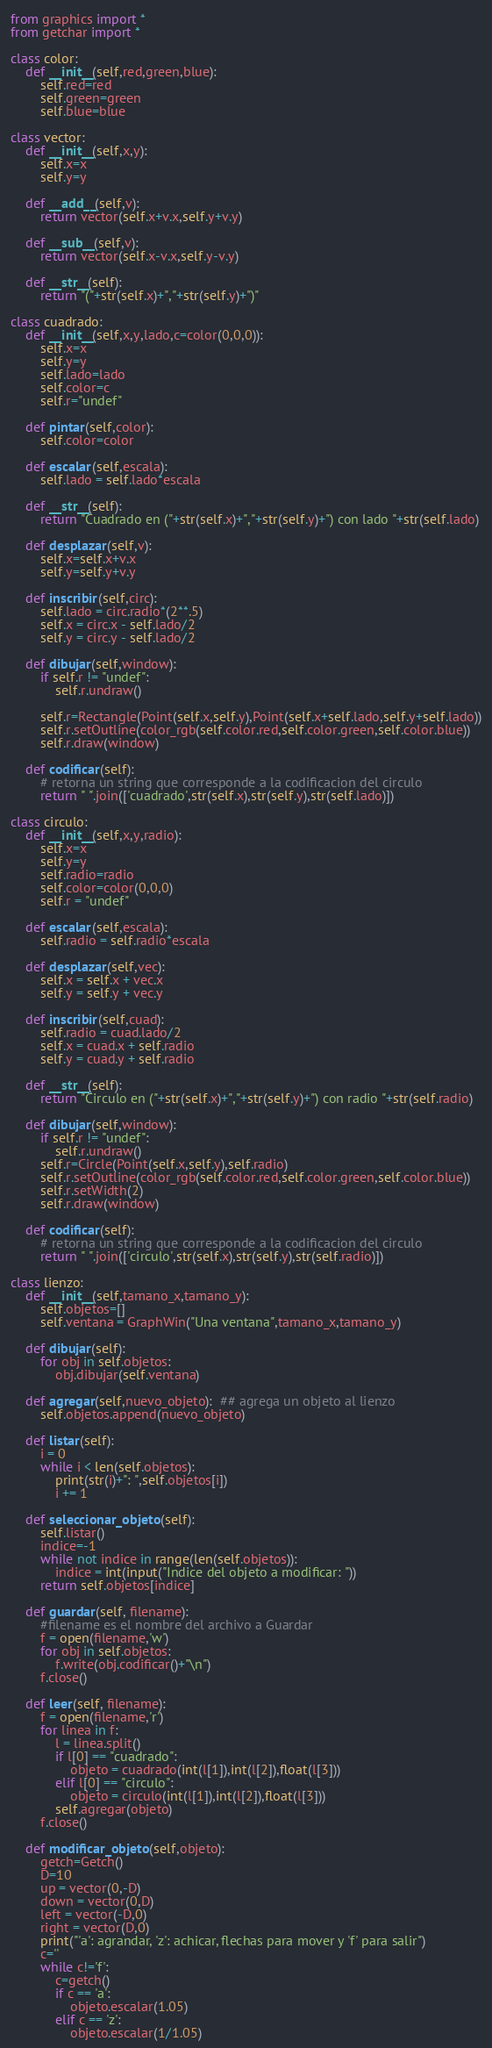Convert code to text. <code><loc_0><loc_0><loc_500><loc_500><_Python_>from graphics import *
from getchar import *

class color:
    def __init__(self,red,green,blue):
        self.red=red
        self.green=green
        self.blue=blue

class vector:
    def __init__(self,x,y):
        self.x=x
        self.y=y

    def __add__(self,v):
        return vector(self.x+v.x,self.y+v.y)

    def __sub__(self,v):
        return vector(self.x-v.x,self.y-v.y)

    def __str__(self):
        return "("+str(self.x)+","+str(self.y)+")"

class cuadrado:
    def __init__(self,x,y,lado,c=color(0,0,0)):
        self.x=x
        self.y=y
        self.lado=lado
        self.color=c
        self.r="undef"

    def pintar(self,color):
        self.color=color

    def escalar(self,escala):
        self.lado = self.lado*escala

    def __str__(self):
        return "Cuadrado en ("+str(self.x)+","+str(self.y)+") con lado "+str(self.lado)

    def desplazar(self,v):
        self.x=self.x+v.x
        self.y=self.y+v.y

    def inscribir(self,circ):
        self.lado = circ.radio*(2**.5)
        self.x = circ.x - self.lado/2
        self.y = circ.y - self.lado/2

    def dibujar(self,window):
        if self.r != "undef":
            self.r.undraw()

        self.r=Rectangle(Point(self.x,self.y),Point(self.x+self.lado,self.y+self.lado))
        self.r.setOutline(color_rgb(self.color.red,self.color.green,self.color.blue))
        self.r.draw(window)

    def codificar(self):
        # retorna un string que corresponde a la codificacion del circulo
        return " ".join(['cuadrado',str(self.x),str(self.y),str(self.lado)])

class circulo:
    def __init__(self,x,y,radio):
        self.x=x
        self.y=y
        self.radio=radio
        self.color=color(0,0,0)
        self.r = "undef"

    def escalar(self,escala):
        self.radio = self.radio*escala

    def desplazar(self,vec):
        self.x = self.x + vec.x
        self.y = self.y + vec.y

    def inscribir(self,cuad):
        self.radio = cuad.lado/2
        self.x = cuad.x + self.radio
        self.y = cuad.y + self.radio

    def __str__(self):
        return "Circulo en ("+str(self.x)+","+str(self.y)+") con radio "+str(self.radio)

    def dibujar(self,window):
        if self.r != "undef":
            self.r.undraw()
        self.r=Circle(Point(self.x,self.y),self.radio)
        self.r.setOutline(color_rgb(self.color.red,self.color.green,self.color.blue))
        self.r.setWidth(2)
        self.r.draw(window)

    def codificar(self):
        # retorna un string que corresponde a la codificacion del circulo
        return " ".join(['circulo',str(self.x),str(self.y),str(self.radio)])

class lienzo:
    def __init__(self,tamano_x,tamano_y):
        self.objetos=[]
        self.ventana = GraphWin("Una ventana",tamano_x,tamano_y)

    def dibujar(self):
        for obj in self.objetos:
            obj.dibujar(self.ventana)

    def agregar(self,nuevo_objeto):  ## agrega un objeto al lienzo
        self.objetos.append(nuevo_objeto)

    def listar(self):
        i = 0
        while i < len(self.objetos):
            print(str(i)+": ",self.objetos[i])
            i += 1

    def seleccionar_objeto(self):
        self.listar()
        indice=-1
        while not indice in range(len(self.objetos)):
            indice = int(input("Indice del objeto a modificar: "))
        return self.objetos[indice]

    def guardar(self, filename):
        #filename es el nombre del archivo a Guardar
        f = open(filename,'w')
        for obj in self.objetos:
            f.write(obj.codificar()+"\n")
        f.close()

    def leer(self, filename):
        f = open(filename,'r')
        for linea in f:
            l = linea.split()
            if l[0] == "cuadrado":
                objeto = cuadrado(int(l[1]),int(l[2]),float(l[3]))
            elif l[0] == "circulo":
                objeto = circulo(int(l[1]),int(l[2]),float(l[3]))
            self.agregar(objeto)
        f.close()

    def modificar_objeto(self,objeto):
        getch=Getch()
        D=10
        up = vector(0,-D)
        down = vector(0,D)
        left = vector(-D,0)
        right = vector(D,0)
        print("'a': agrandar, 'z': achicar, flechas para mover y 'f' para salir")
        c=''
        while c!='f':
            c=getch()
            if c == 'a':
                objeto.escalar(1.05)
            elif c == 'z':
                objeto.escalar(1/1.05)</code> 